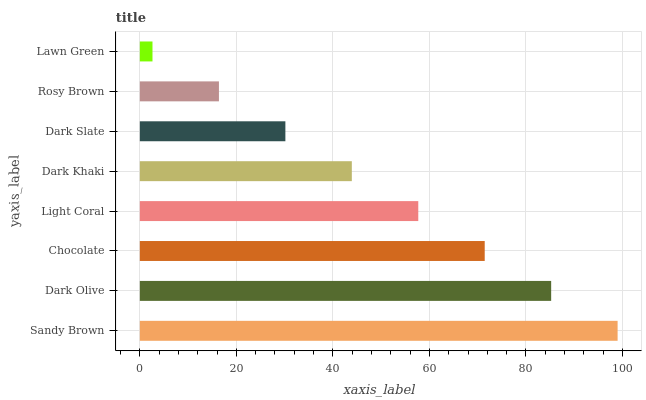Is Lawn Green the minimum?
Answer yes or no. Yes. Is Sandy Brown the maximum?
Answer yes or no. Yes. Is Dark Olive the minimum?
Answer yes or no. No. Is Dark Olive the maximum?
Answer yes or no. No. Is Sandy Brown greater than Dark Olive?
Answer yes or no. Yes. Is Dark Olive less than Sandy Brown?
Answer yes or no. Yes. Is Dark Olive greater than Sandy Brown?
Answer yes or no. No. Is Sandy Brown less than Dark Olive?
Answer yes or no. No. Is Light Coral the high median?
Answer yes or no. Yes. Is Dark Khaki the low median?
Answer yes or no. Yes. Is Rosy Brown the high median?
Answer yes or no. No. Is Sandy Brown the low median?
Answer yes or no. No. 